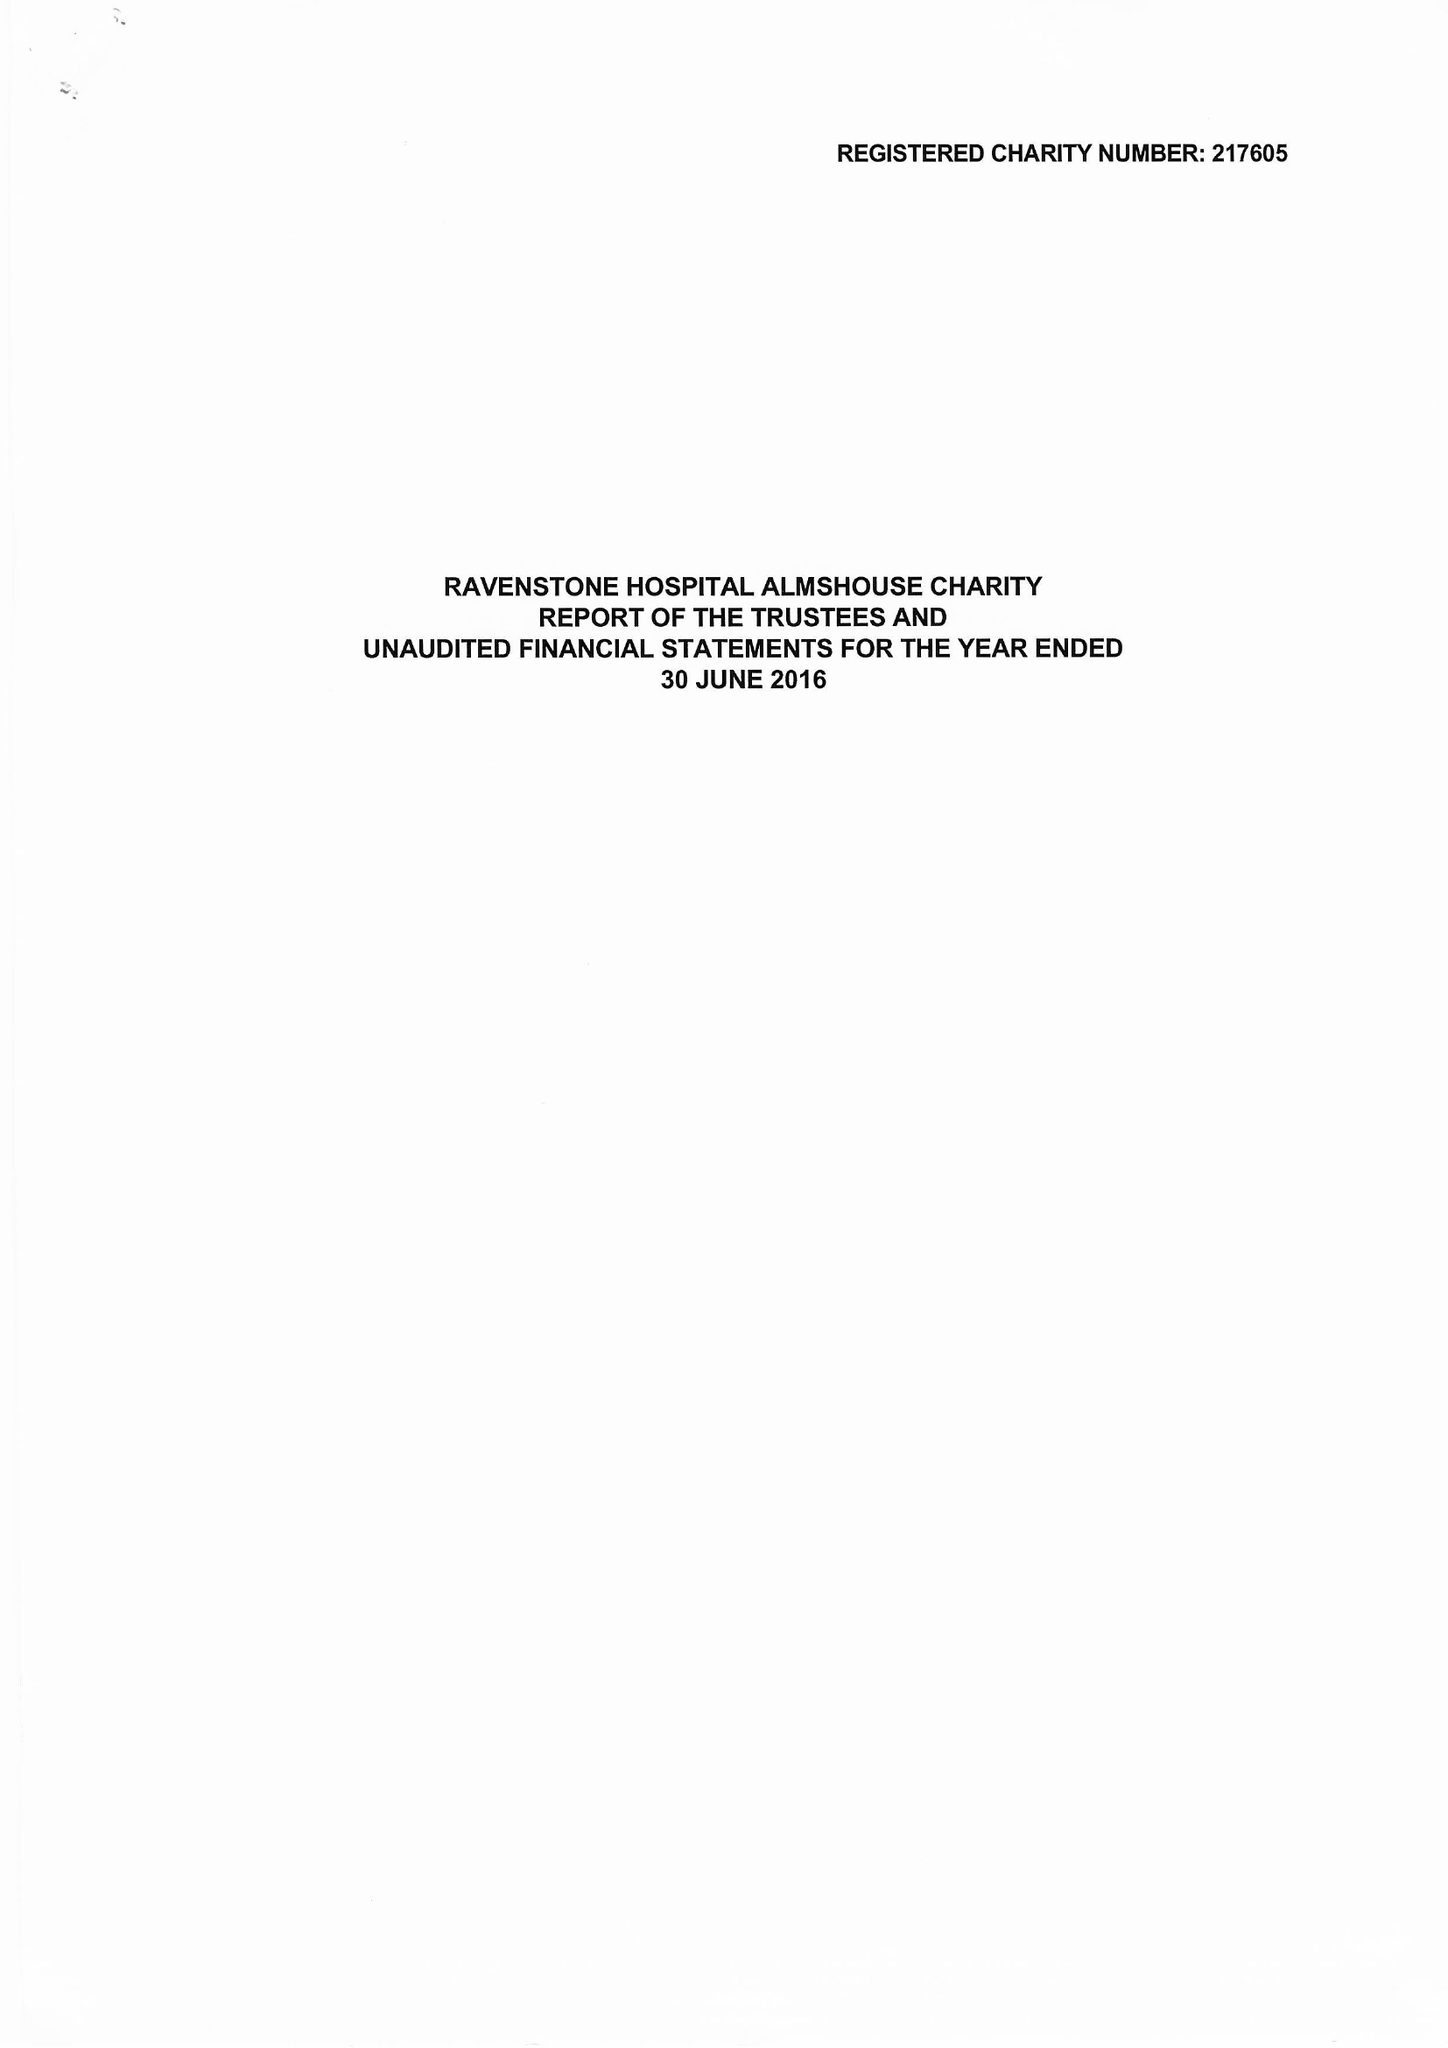What is the value for the report_date?
Answer the question using a single word or phrase. 2017-06-30 